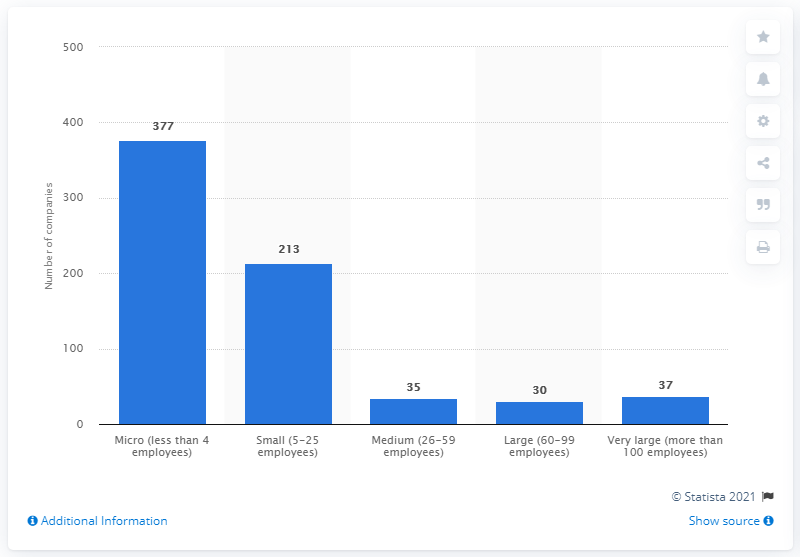Identify some key points in this picture. In 2019, there were 377 micro-sized video game companies operating in Canada. 